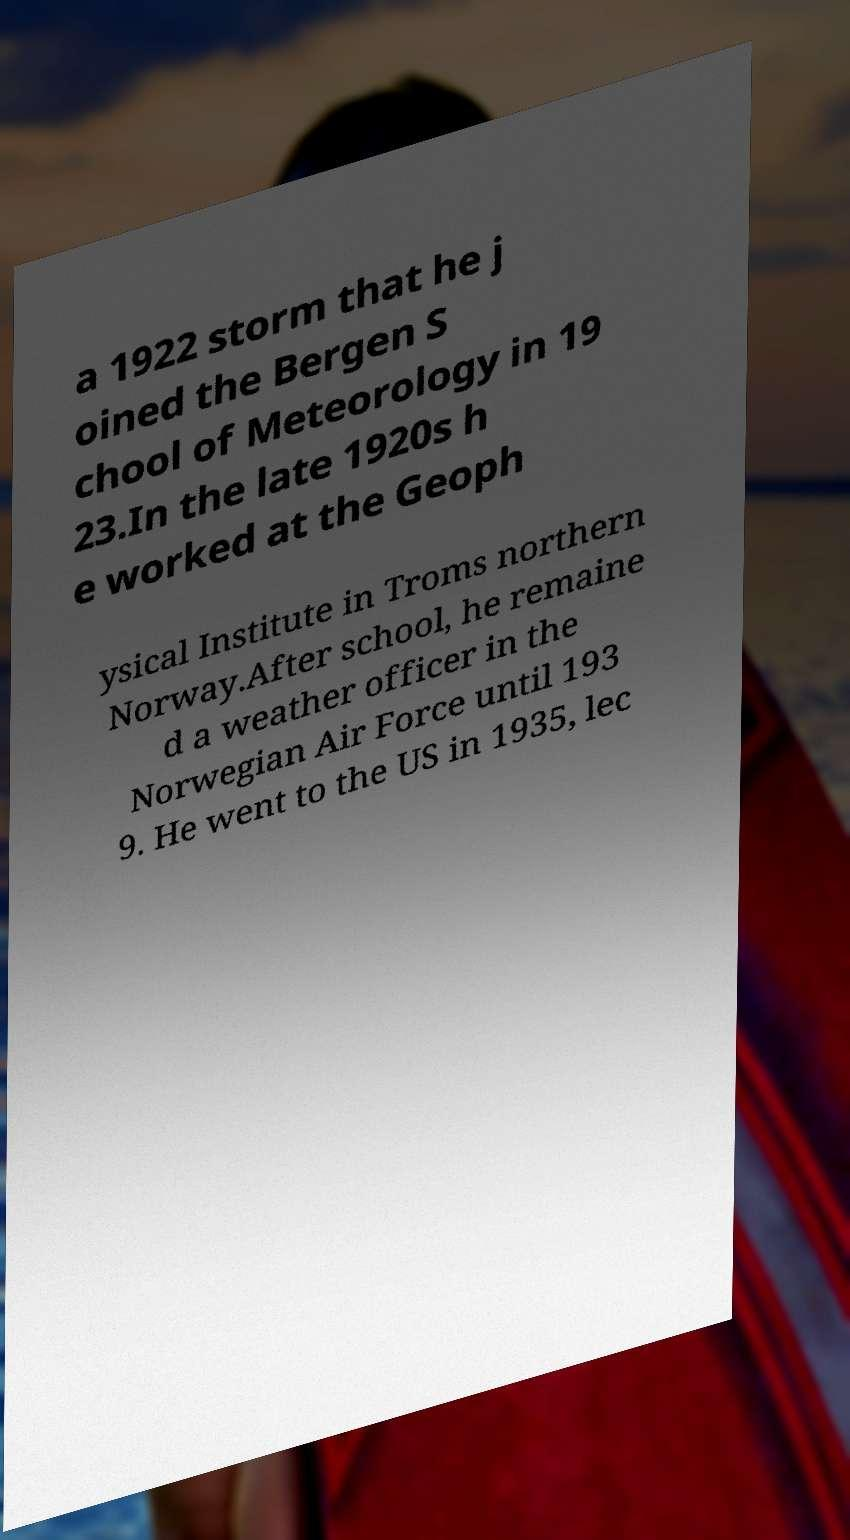Please read and relay the text visible in this image. What does it say? a 1922 storm that he j oined the Bergen S chool of Meteorology in 19 23.In the late 1920s h e worked at the Geoph ysical Institute in Troms northern Norway.After school, he remaine d a weather officer in the Norwegian Air Force until 193 9. He went to the US in 1935, lec 